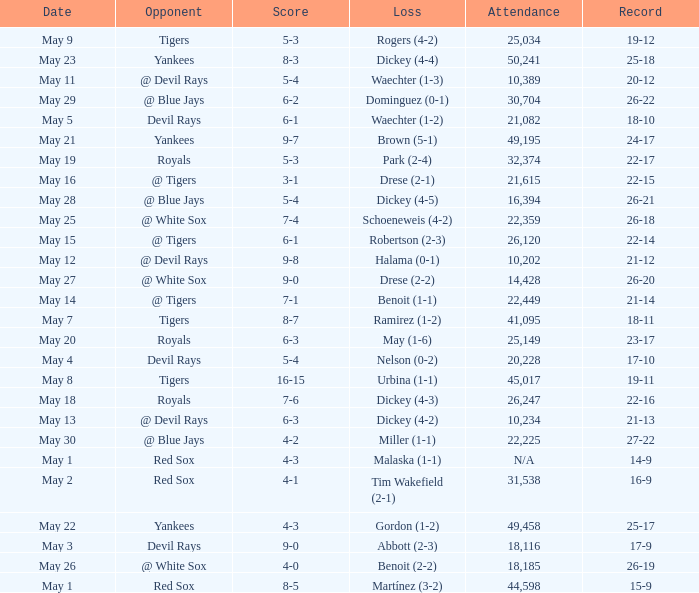What was the score of the game that had a loss of Drese (2-2)? 9-0. 